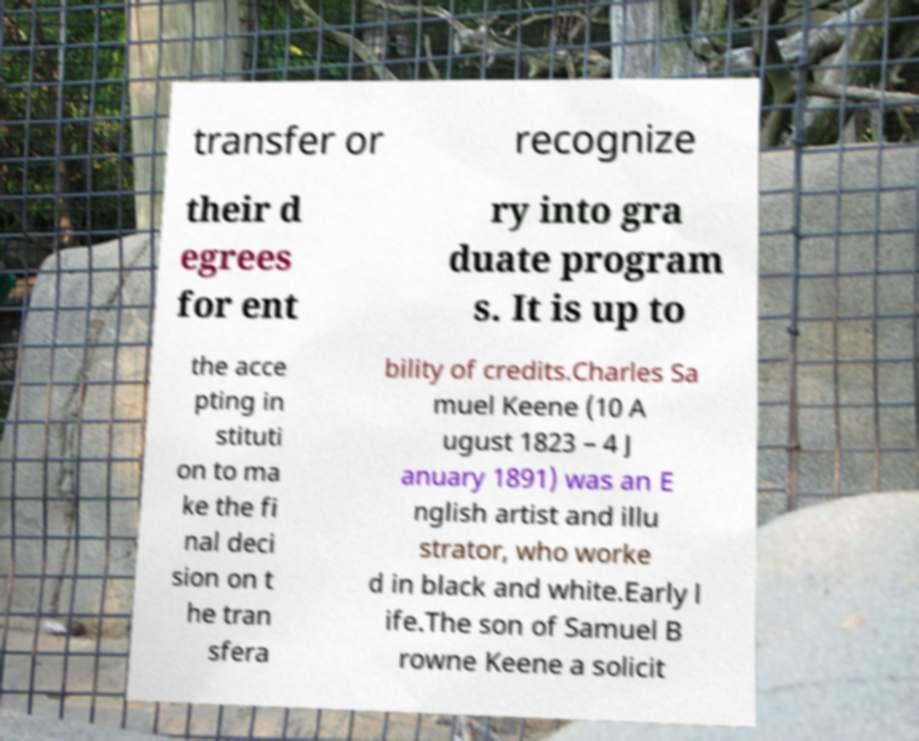Can you read and provide the text displayed in the image?This photo seems to have some interesting text. Can you extract and type it out for me? transfer or recognize their d egrees for ent ry into gra duate program s. It is up to the acce pting in stituti on to ma ke the fi nal deci sion on t he tran sfera bility of credits.Charles Sa muel Keene (10 A ugust 1823 – 4 J anuary 1891) was an E nglish artist and illu strator, who worke d in black and white.Early l ife.The son of Samuel B rowne Keene a solicit 